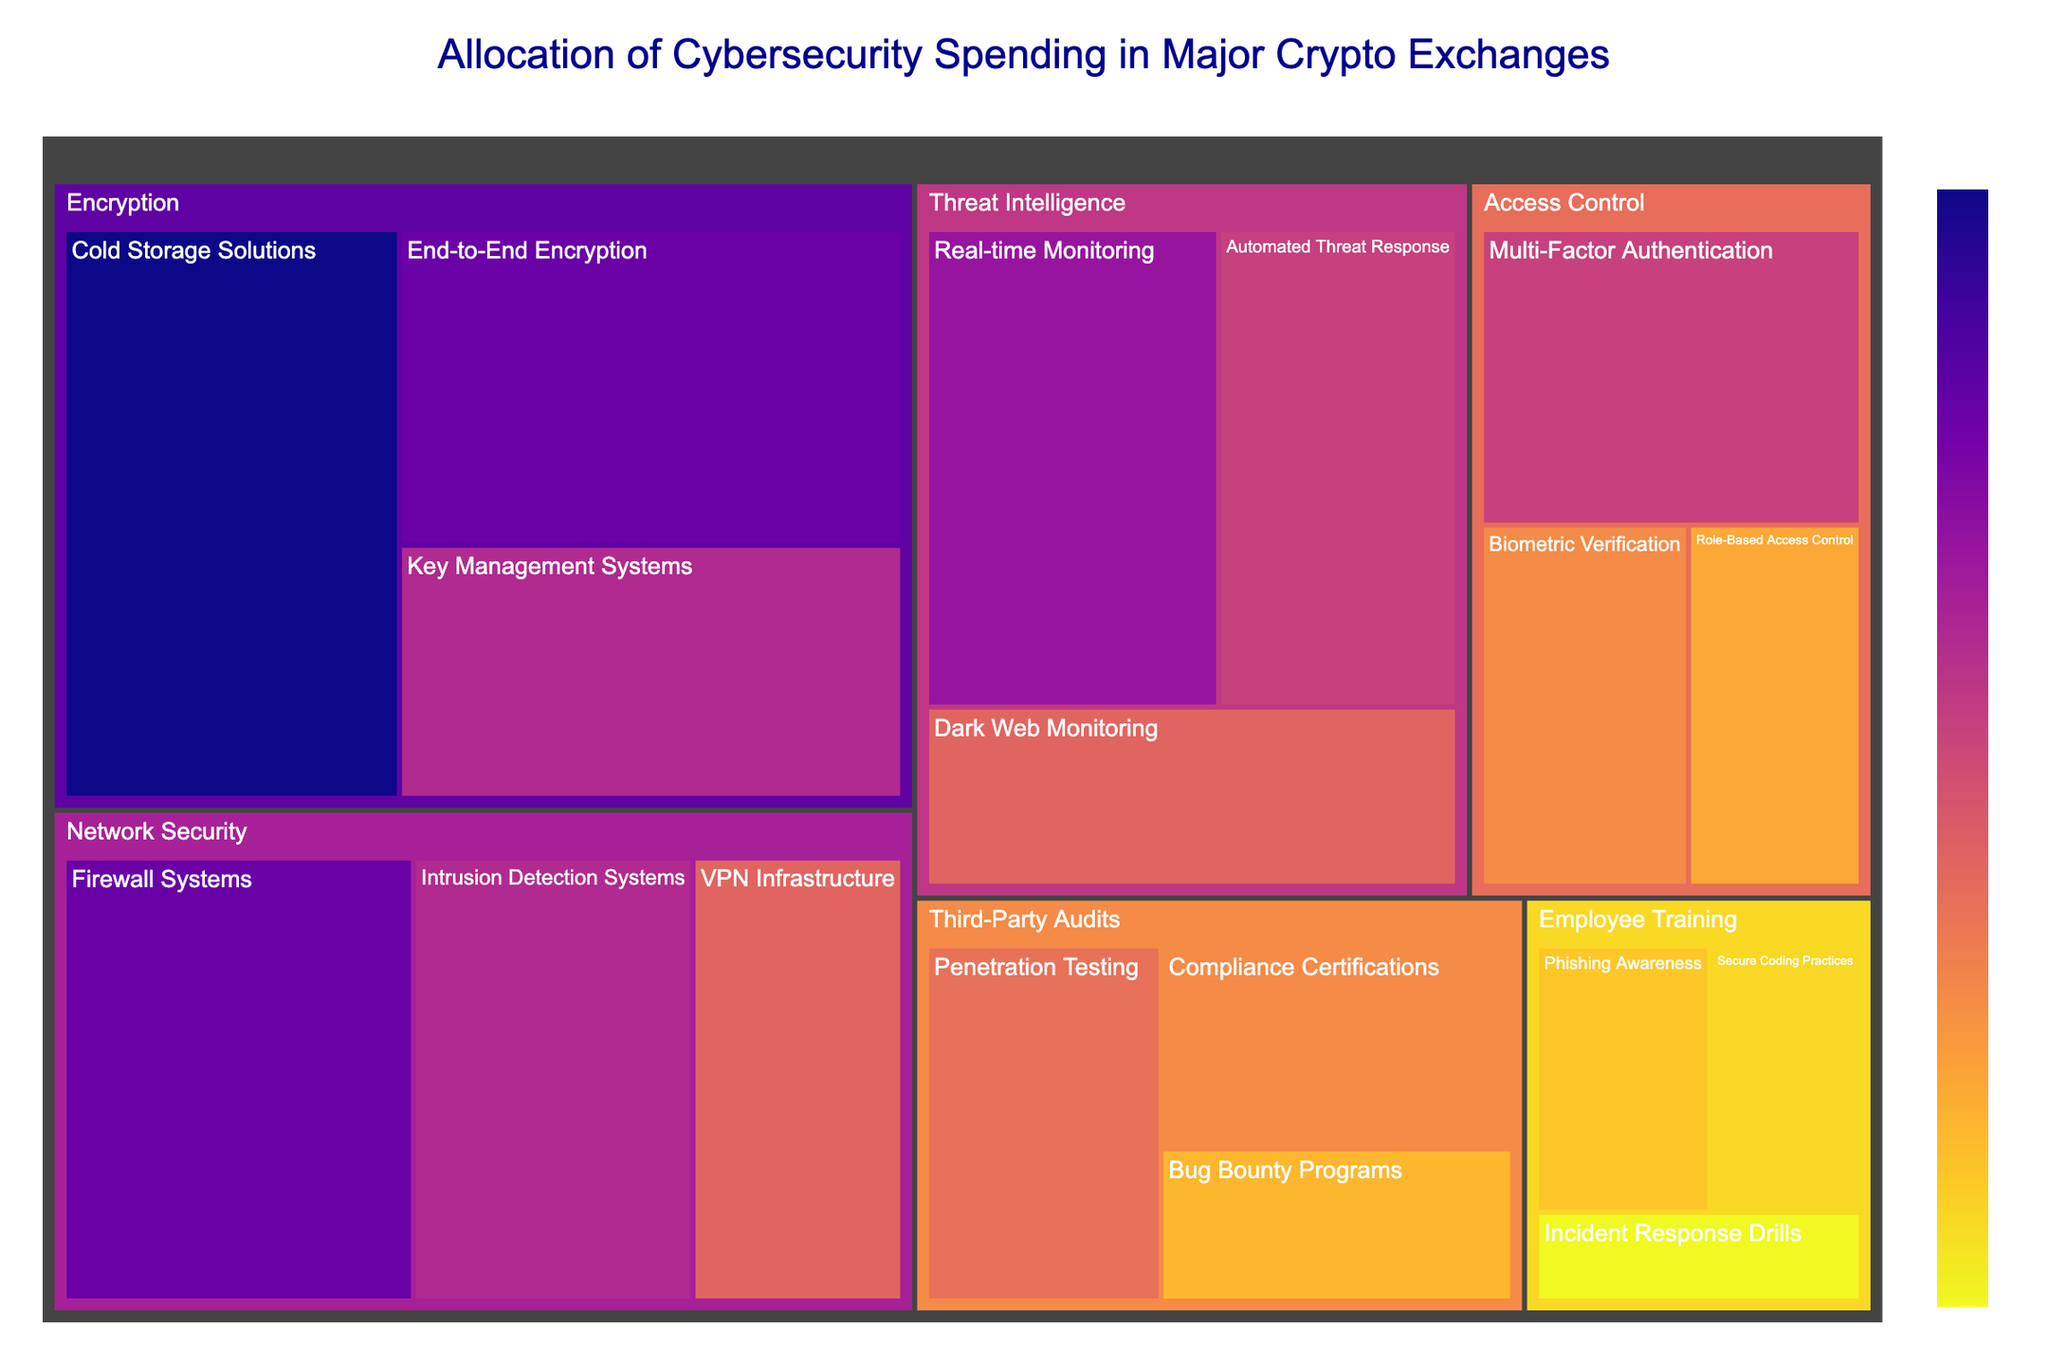What is the title of the figure? The title of the figure is the text displayed at the top of the Treemap.
Answer: Allocation of Cybersecurity Spending in Major Crypto Exchanges Which category has the highest total spending? The Network Security category has the largest combined size of rectangles, indicating its items sum to the highest value.
Answer: Network Security What is the total spending on Encryption? Sum the values for the three subcategories under Encryption: (30 + 25 + 20). So, the total is 75.
Answer: 75 Compare spending on Cold Storage Solutions and Incident Response Drills. Which one is higher and by how much? Cold Storage Solutions has a value of 30, whereas Incident Response Drills have a value of 5. The difference is 30 - 5 = 25.
Answer: Cold Storage Solutions is higher by 25 What is the smallest subcategory spending and which category does it belong to? The smallest subcategory is Incident Response Drills with a value of 5. It belongs to the Employee Training category.
Answer: Incident Response Drills, Employee Training What is the average spending on Threat Intelligence measures? Sum the values for Threat Intelligence subcategories (22 + 18 + 15) which is 55, then divide by the number of subcategories: 55 / 3 = 18.33.
Answer: 18.33 Which subcategory in Access Control has the lowest spending? The rectangles under Access Control show Biometric Verification with a value of 12 is the lowest.
Answer: Biometric Verification Is the spending on Automated Threat Response higher than on Multi-Factor Authentication? Automated Threat Response has a spending of 18 while Multi-Factor Authentication has a spending of 18 as well. They are equal.
Answer: No, they are equal How does the spending on Firewalls compare to the spending on Phishing Awareness? Firewalls have a value of 25, whereas Phishing Awareness has a value of 8. Since 25 > 8, Firewalls spending is higher.
Answer: Firewalls is higher What is the combined spending on Third-Party Audits? Sum the values for the subcategories under Third-Party Audits: (14 + 12 + 9). So, the total is 35.
Answer: 35 